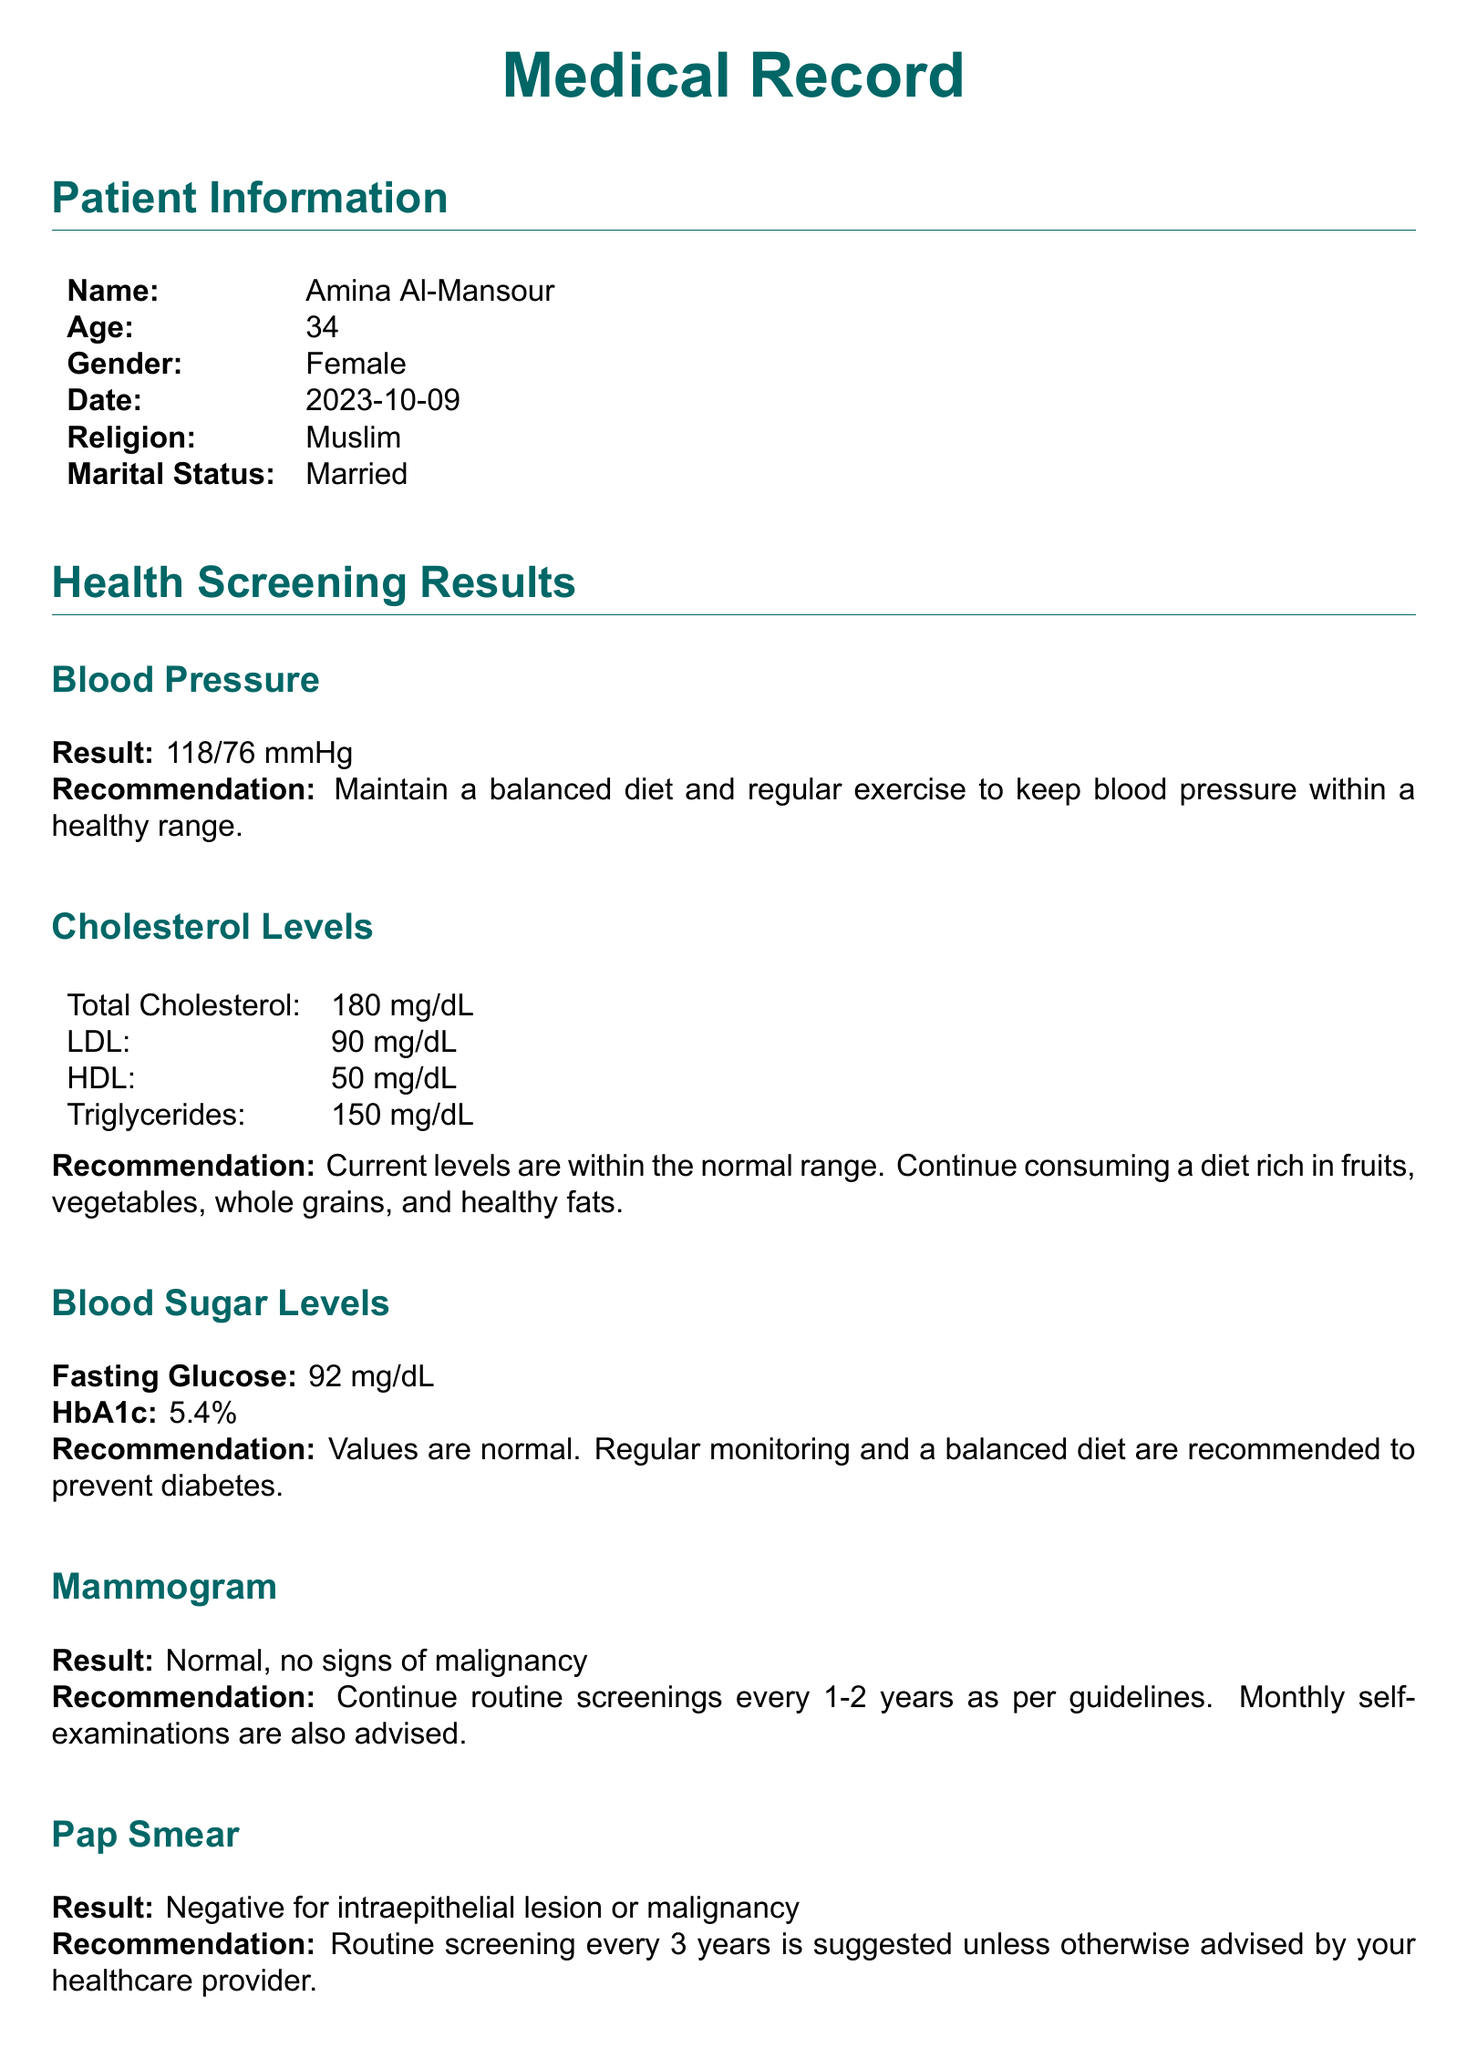What is the patient's name? The patient's name is mentioned in the Patient Information section.
Answer: Amina Al-Mansour What is the result of the blood pressure screening? The blood pressure result can be found under the Blood Pressure subsection.
Answer: 118/76 mmHg What is the recommendation for the mammogram result? The recommendation for the mammogram is provided directly after the result in the Mammogram subsection.
Answer: Continue routine screenings every 1-2 years as per guidelines What is the fasting glucose level? The fasting glucose level is listed under Blood Sugar Levels in the document.
Answer: 92 mg/dL How often should Pap smears be conducted according to the recommendations? The recommended frequency for Pap smears is mentioned directly after the result in the Pap Smear subsection.
Answer: Every 3 years What is the main dietary advice provided? The dietary advice can be found in the Lifestyle Recommendations section.
Answer: Adopt a Mediterranean-style diet What exercise duration per week is suggested? The suggested exercise duration is noted in the Lifestyle Recommendations section.
Answer: 150 minutes What was the result of the mental health screening? The result of the mental health screening is found under the Mental Health Screening subsection.
Answer: No significant signs of depression or anxiety What is the date for the next appointment? The date for the next appointment is mentioned in the Follow Up section.
Answer: 2024-10-09 